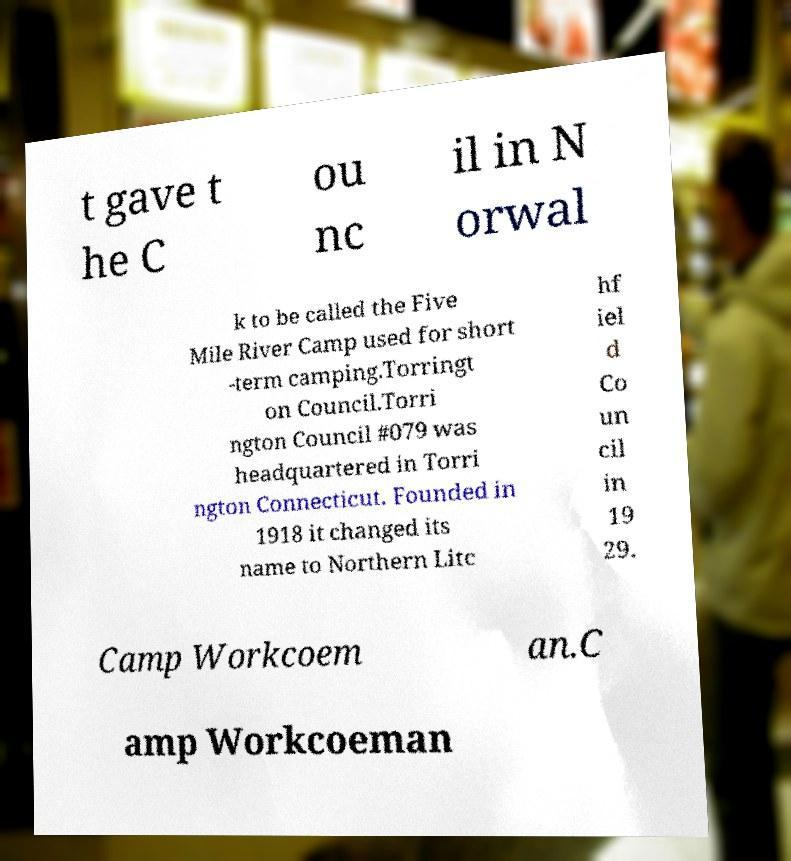I need the written content from this picture converted into text. Can you do that? t gave t he C ou nc il in N orwal k to be called the Five Mile River Camp used for short -term camping.Torringt on Council.Torri ngton Council #079 was headquartered in Torri ngton Connecticut. Founded in 1918 it changed its name to Northern Litc hf iel d Co un cil in 19 29. Camp Workcoem an.C amp Workcoeman 